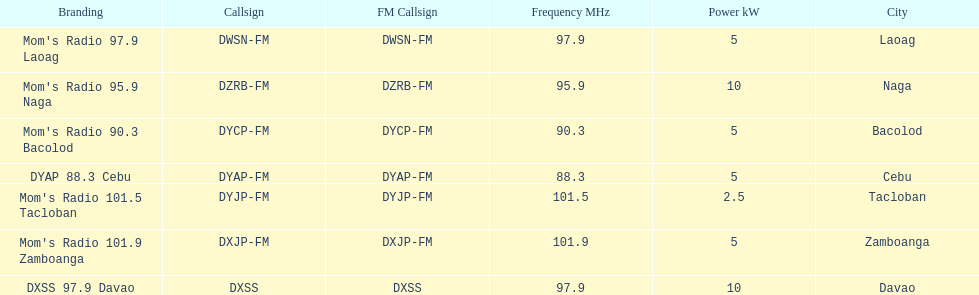Which of these stations broadcasts with the least power? Mom's Radio 101.5 Tacloban. 